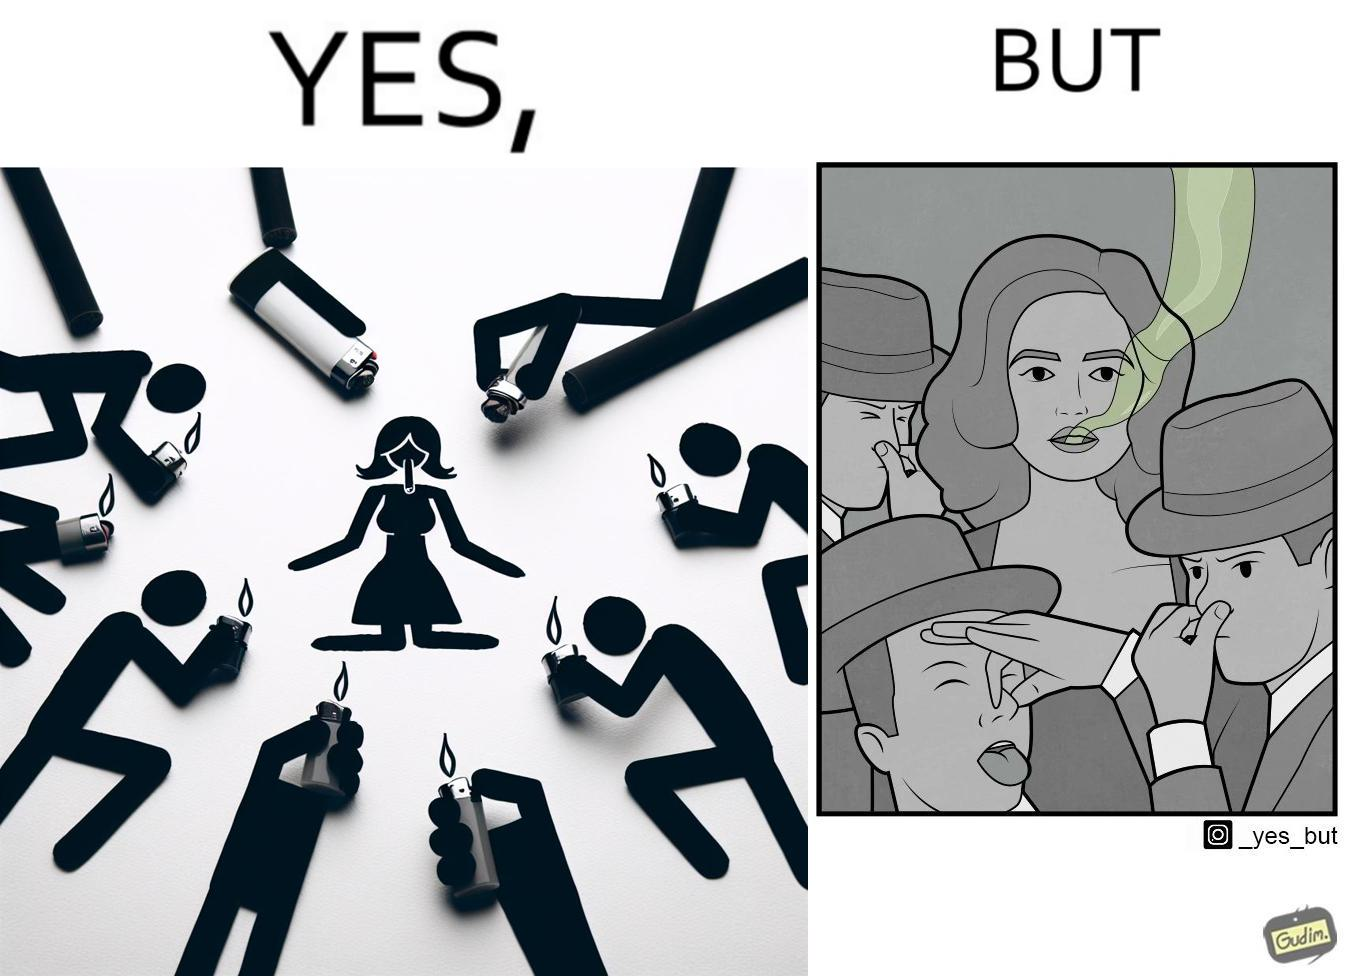Describe the satirical element in this image. The image is ironical, as people seem to be holding lighters to light up a woman's cigarette at an attempt to probably  impress her, while showing that the very same people are holding their noses on account of what appears to be bad smell coming out of the woman's mouth. 